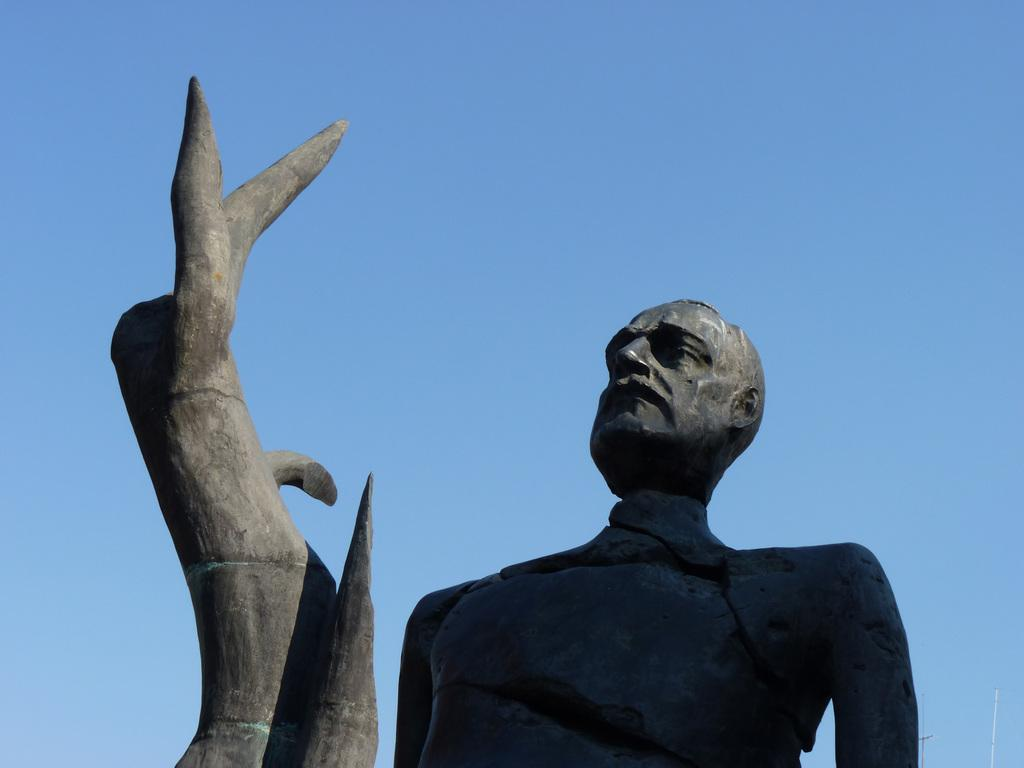What is the main subject of the image? There is a statue of a person in the image. What else can be seen in the image besides the statue? There is an object in the image. What is visible in the background of the image? The sky is visible behind the statue. Can you tell me how many wilderness areas are depicted in the image? There is no wilderness area depicted in the image; it features a statue of a person and an object. Is the person wearing a mask in the image? There is no indication of a mask being worn by the person in the image, as it is a statue. 